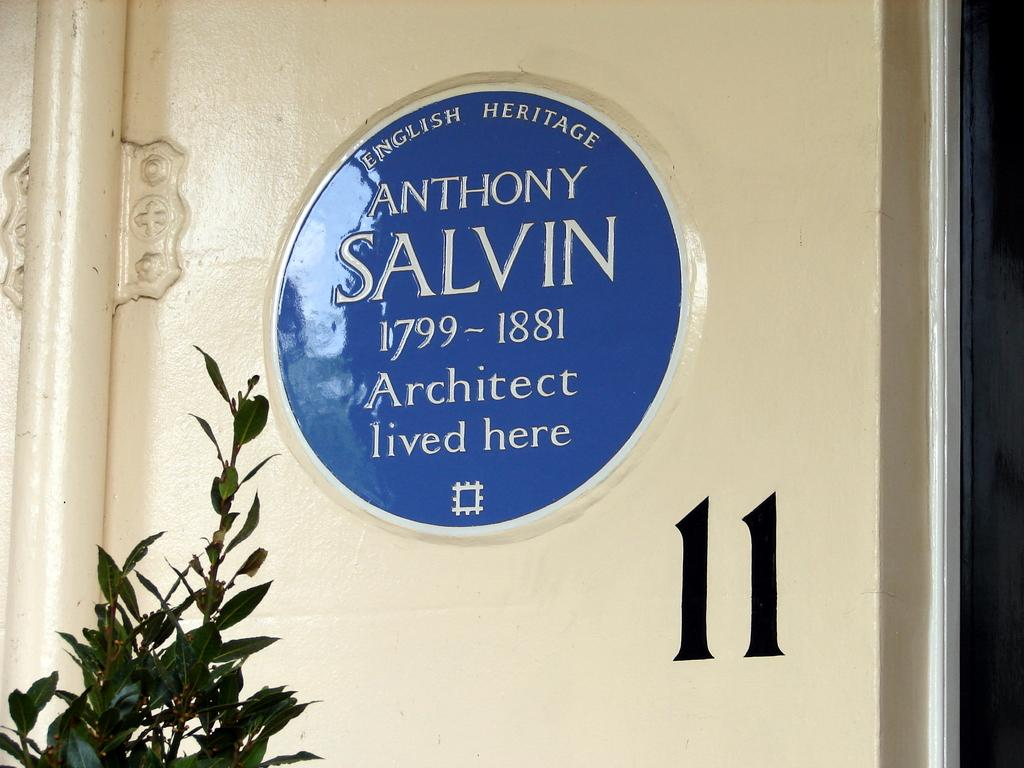What is the main object in the center of the image? There is a door in the center of the image. What is written or depicted on the door? There is text on the door. What type of vegetation can be seen at the bottom of the image? There is a plant at the bottom of the image. What other object is visible on the left side of the image? There is a pipe on the left side of the image. What time of day is it in the image, and how many pets are visible? The time of day is not mentioned in the image, and there are no pets visible. 